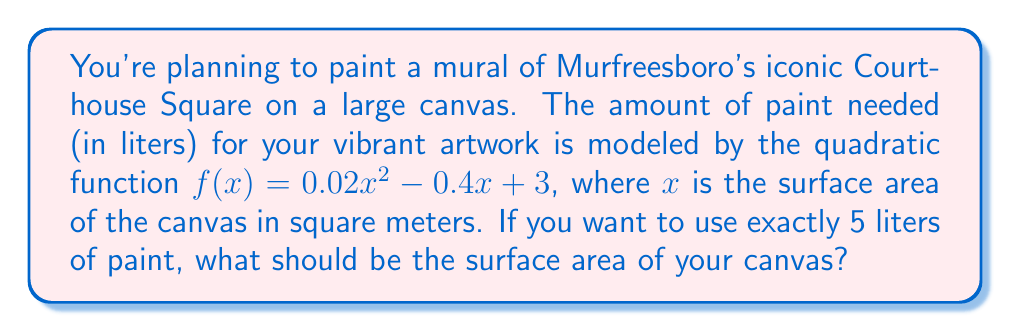What is the answer to this math problem? To solve this problem, we need to find the value of $x$ when $f(x) = 5$. Let's approach this step-by-step:

1) We start with the equation:
   $0.02x^2 - 0.4x + 3 = 5$

2) Subtract 5 from both sides to get the equation in standard form:
   $0.02x^2 - 0.4x - 2 = 0$

3) This is a quadratic equation. We can solve it using the quadratic formula:
   $x = \frac{-b \pm \sqrt{b^2 - 4ac}}{2a}$

   Where $a = 0.02$, $b = -0.4$, and $c = -2$

4) Substituting these values:
   $x = \frac{0.4 \pm \sqrt{(-0.4)^2 - 4(0.02)(-2)}}{2(0.02)}$

5) Simplify under the square root:
   $x = \frac{0.4 \pm \sqrt{0.16 + 0.16}}{0.04} = \frac{0.4 \pm \sqrt{0.32}}{0.04}$

6) Simplify further:
   $x = \frac{0.4 \pm 0.5656}{0.04} = 10 \pm 14.14$

7) This gives us two solutions:
   $x_1 = 10 + 14.14 = 24.14$
   $x_2 = 10 - 14.14 = -4.14$

8) Since surface area cannot be negative, we discard the negative solution.

Therefore, the surface area of the canvas should be approximately 24.14 square meters.
Answer: 24.14 m² 